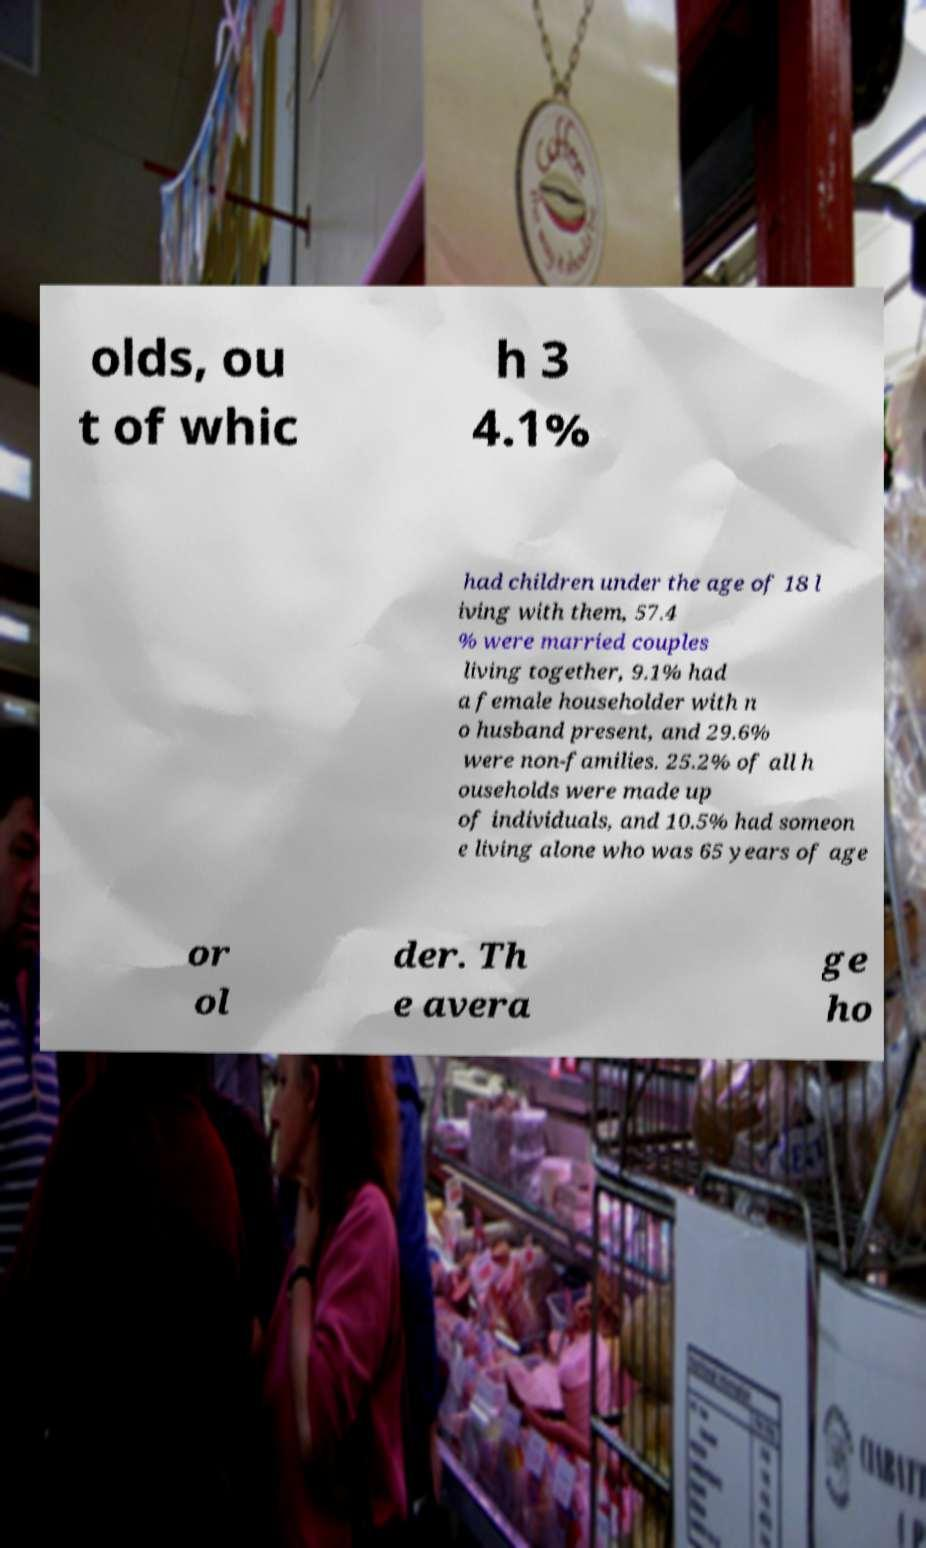Could you assist in decoding the text presented in this image and type it out clearly? olds, ou t of whic h 3 4.1% had children under the age of 18 l iving with them, 57.4 % were married couples living together, 9.1% had a female householder with n o husband present, and 29.6% were non-families. 25.2% of all h ouseholds were made up of individuals, and 10.5% had someon e living alone who was 65 years of age or ol der. Th e avera ge ho 